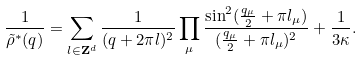<formula> <loc_0><loc_0><loc_500><loc_500>\frac { 1 } { \tilde { \rho } ^ { * } ( q ) } = \sum _ { l \in { \mathbf Z } ^ { d } } \frac { 1 } { ( q + 2 \pi l ) ^ { 2 } } \prod _ { \mu } \frac { \sin ^ { 2 } ( \frac { q _ { \mu } } { 2 } + \pi l _ { \mu } ) } { ( \frac { q _ { \mu } } { 2 } + \pi l _ { \mu } ) ^ { 2 } } + \frac { 1 } { 3 \kappa } .</formula> 